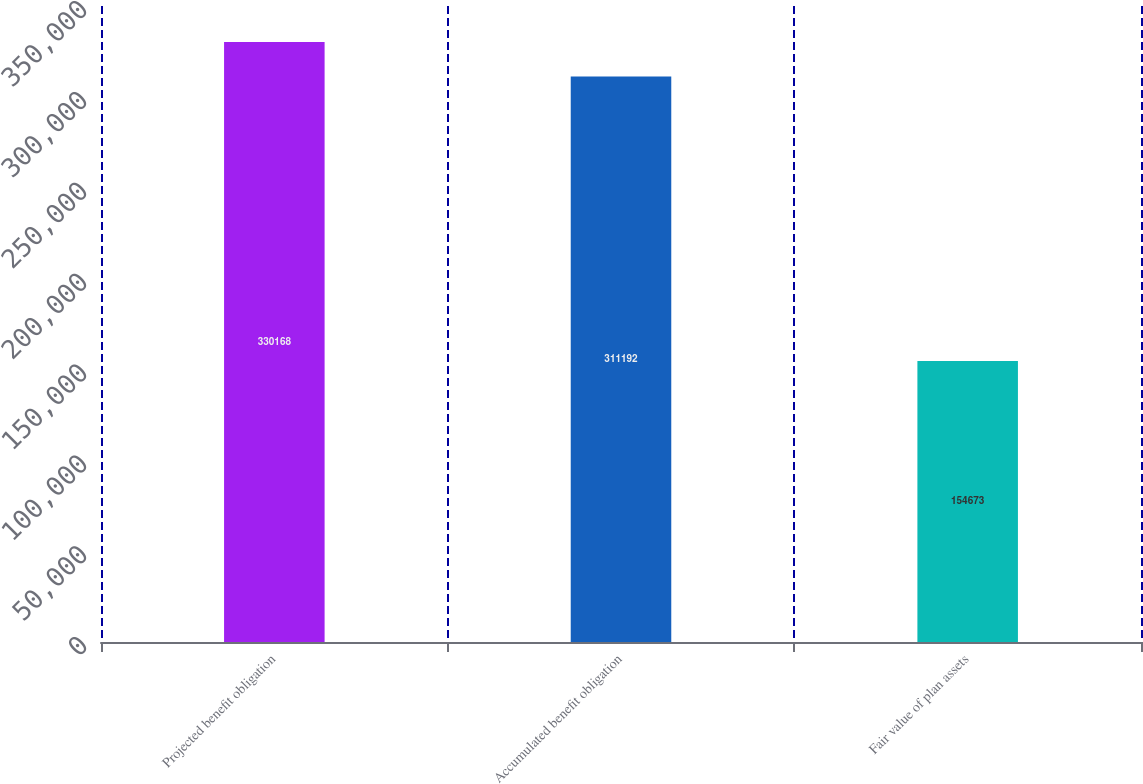<chart> <loc_0><loc_0><loc_500><loc_500><bar_chart><fcel>Projected benefit obligation<fcel>Accumulated benefit obligation<fcel>Fair value of plan assets<nl><fcel>330168<fcel>311192<fcel>154673<nl></chart> 